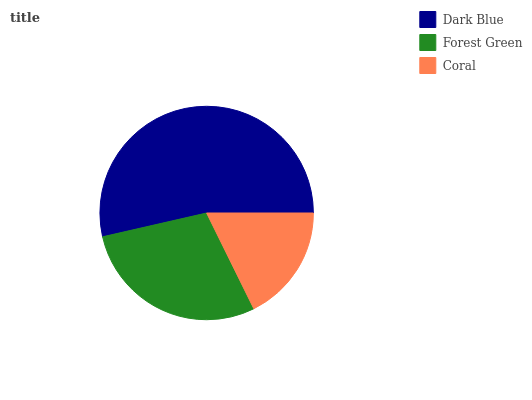Is Coral the minimum?
Answer yes or no. Yes. Is Dark Blue the maximum?
Answer yes or no. Yes. Is Forest Green the minimum?
Answer yes or no. No. Is Forest Green the maximum?
Answer yes or no. No. Is Dark Blue greater than Forest Green?
Answer yes or no. Yes. Is Forest Green less than Dark Blue?
Answer yes or no. Yes. Is Forest Green greater than Dark Blue?
Answer yes or no. No. Is Dark Blue less than Forest Green?
Answer yes or no. No. Is Forest Green the high median?
Answer yes or no. Yes. Is Forest Green the low median?
Answer yes or no. Yes. Is Dark Blue the high median?
Answer yes or no. No. Is Coral the low median?
Answer yes or no. No. 